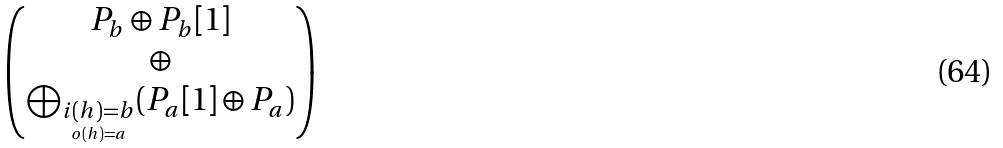<formula> <loc_0><loc_0><loc_500><loc_500>\begin{pmatrix} P _ { b } \oplus P _ { b } [ 1 ] \\ \oplus \\ \bigoplus _ { \underset { o ( h ) = a } { i ( h ) = b } } ( P _ { a } [ 1 ] \oplus P _ { a } ) \end{pmatrix}</formula> 